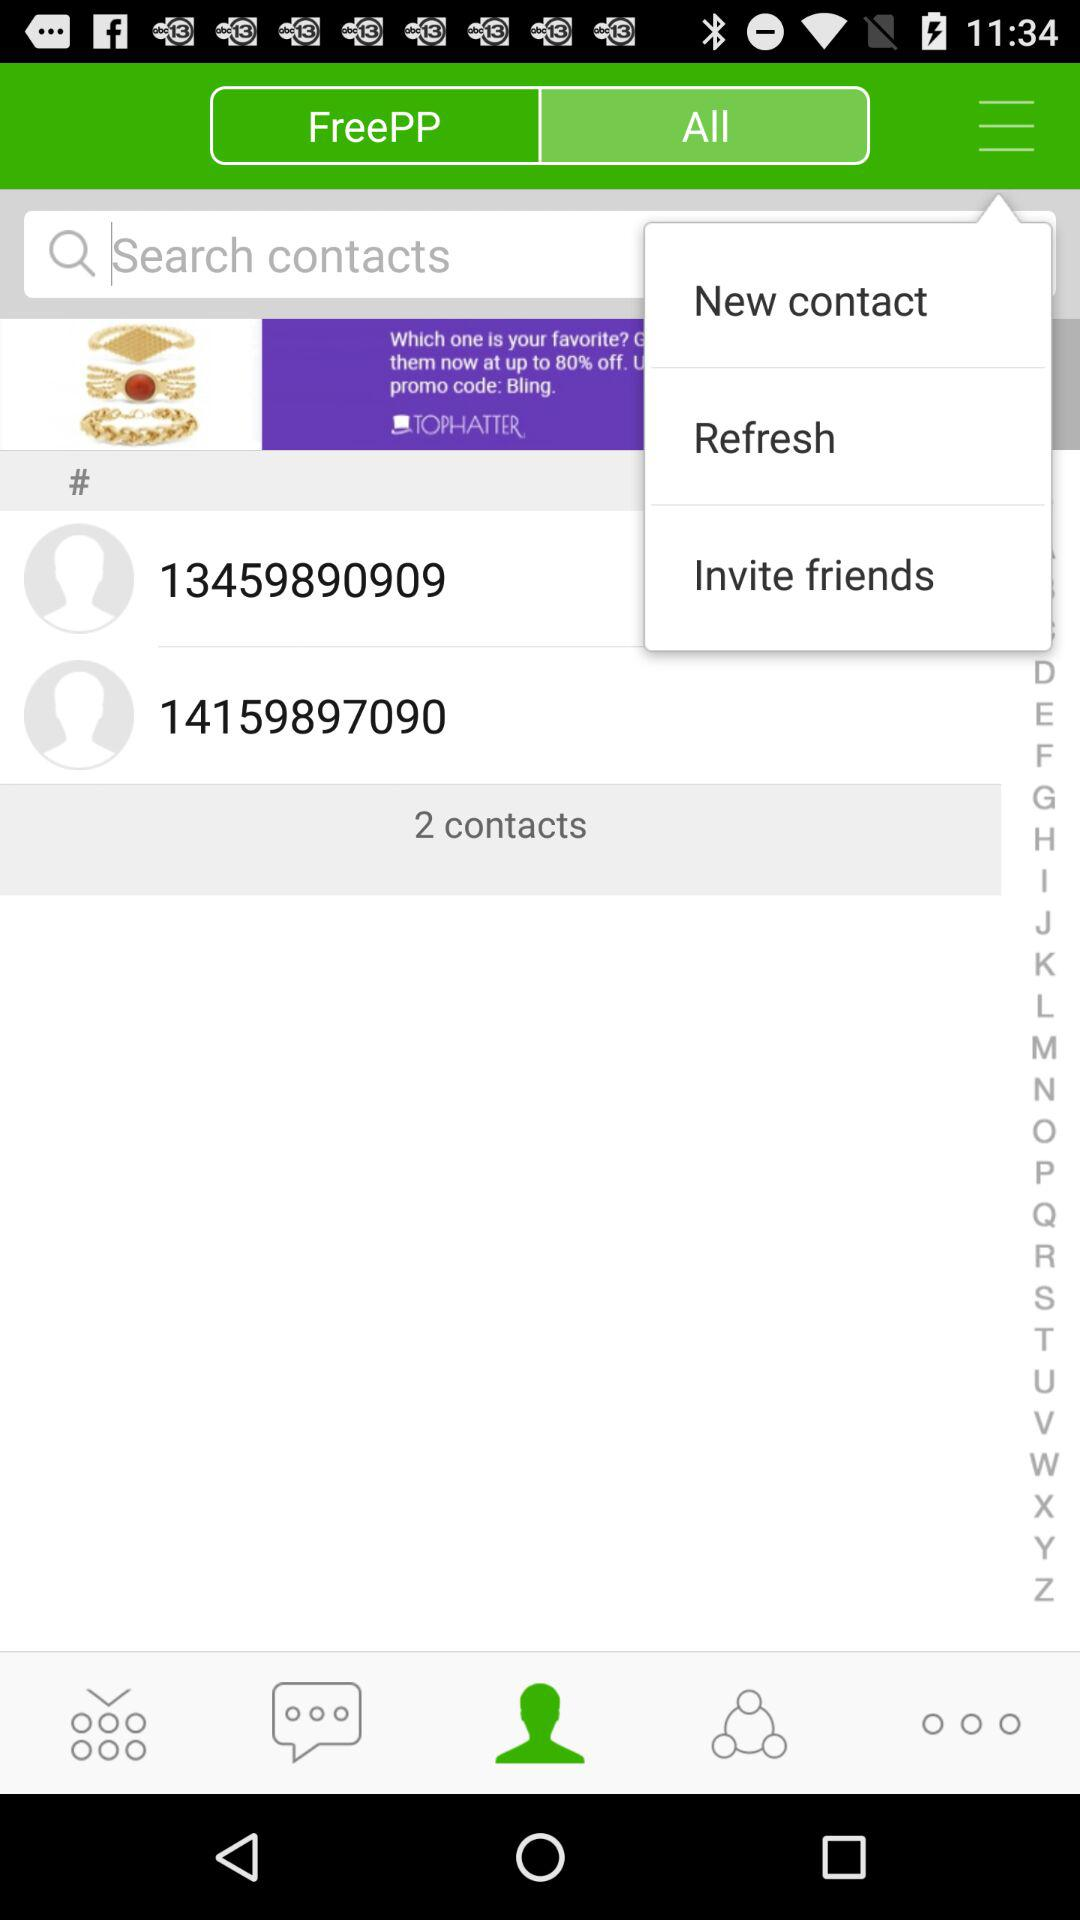How many friends have been invited?
When the provided information is insufficient, respond with <no answer>. <no answer> 